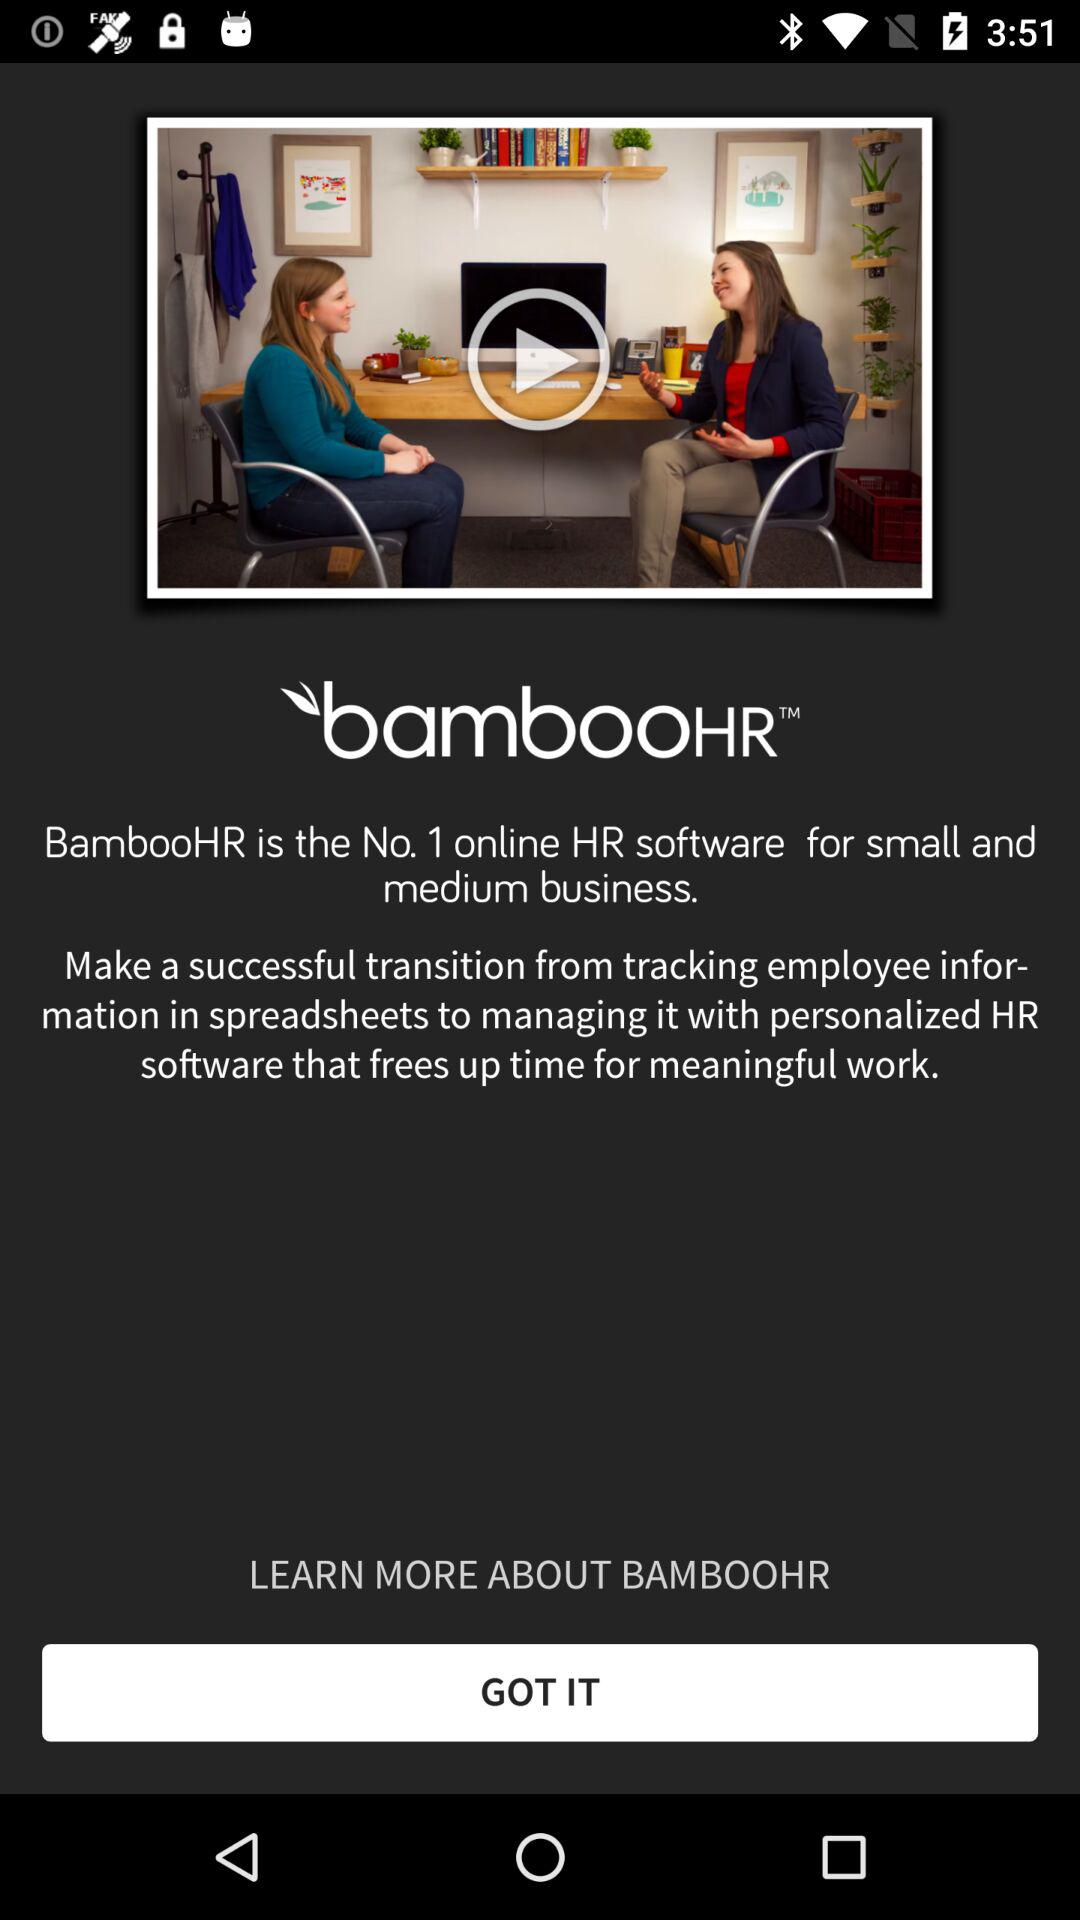What is the name of the application? The name of the application is "BambooHR". 